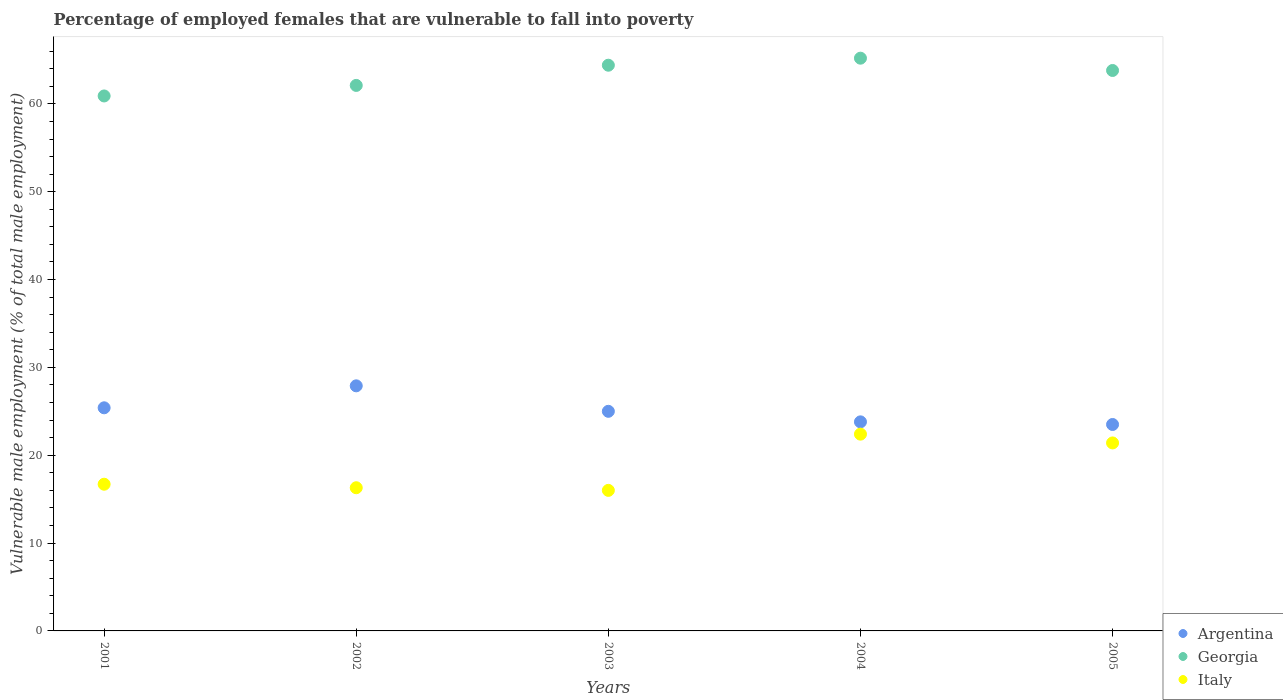How many different coloured dotlines are there?
Ensure brevity in your answer.  3. Is the number of dotlines equal to the number of legend labels?
Offer a terse response. Yes. What is the percentage of employed females who are vulnerable to fall into poverty in Argentina in 2004?
Give a very brief answer. 23.8. Across all years, what is the maximum percentage of employed females who are vulnerable to fall into poverty in Georgia?
Offer a terse response. 65.2. In which year was the percentage of employed females who are vulnerable to fall into poverty in Italy minimum?
Offer a terse response. 2003. What is the total percentage of employed females who are vulnerable to fall into poverty in Argentina in the graph?
Your answer should be very brief. 125.6. What is the difference between the percentage of employed females who are vulnerable to fall into poverty in Georgia in 2002 and that in 2005?
Make the answer very short. -1.7. What is the difference between the percentage of employed females who are vulnerable to fall into poverty in Italy in 2003 and the percentage of employed females who are vulnerable to fall into poverty in Argentina in 2005?
Keep it short and to the point. -7.5. What is the average percentage of employed females who are vulnerable to fall into poverty in Georgia per year?
Provide a succinct answer. 63.28. In the year 2004, what is the difference between the percentage of employed females who are vulnerable to fall into poverty in Argentina and percentage of employed females who are vulnerable to fall into poverty in Italy?
Offer a very short reply. 1.4. What is the ratio of the percentage of employed females who are vulnerable to fall into poverty in Georgia in 2001 to that in 2005?
Give a very brief answer. 0.95. Is the percentage of employed females who are vulnerable to fall into poverty in Italy in 2001 less than that in 2003?
Provide a short and direct response. No. Is the difference between the percentage of employed females who are vulnerable to fall into poverty in Argentina in 2002 and 2003 greater than the difference between the percentage of employed females who are vulnerable to fall into poverty in Italy in 2002 and 2003?
Offer a terse response. Yes. What is the difference between the highest and the lowest percentage of employed females who are vulnerable to fall into poverty in Georgia?
Make the answer very short. 4.3. Is it the case that in every year, the sum of the percentage of employed females who are vulnerable to fall into poverty in Italy and percentage of employed females who are vulnerable to fall into poverty in Argentina  is greater than the percentage of employed females who are vulnerable to fall into poverty in Georgia?
Offer a very short reply. No. Does the percentage of employed females who are vulnerable to fall into poverty in Italy monotonically increase over the years?
Give a very brief answer. No. Is the percentage of employed females who are vulnerable to fall into poverty in Argentina strictly greater than the percentage of employed females who are vulnerable to fall into poverty in Italy over the years?
Your answer should be very brief. Yes. Is the percentage of employed females who are vulnerable to fall into poverty in Argentina strictly less than the percentage of employed females who are vulnerable to fall into poverty in Georgia over the years?
Your answer should be very brief. Yes. How many dotlines are there?
Your response must be concise. 3. How many years are there in the graph?
Offer a terse response. 5. What is the difference between two consecutive major ticks on the Y-axis?
Your response must be concise. 10. Where does the legend appear in the graph?
Your response must be concise. Bottom right. How many legend labels are there?
Provide a succinct answer. 3. How are the legend labels stacked?
Your answer should be compact. Vertical. What is the title of the graph?
Ensure brevity in your answer.  Percentage of employed females that are vulnerable to fall into poverty. Does "Albania" appear as one of the legend labels in the graph?
Provide a succinct answer. No. What is the label or title of the Y-axis?
Provide a short and direct response. Vulnerable male employment (% of total male employment). What is the Vulnerable male employment (% of total male employment) in Argentina in 2001?
Make the answer very short. 25.4. What is the Vulnerable male employment (% of total male employment) in Georgia in 2001?
Your answer should be compact. 60.9. What is the Vulnerable male employment (% of total male employment) in Italy in 2001?
Provide a short and direct response. 16.7. What is the Vulnerable male employment (% of total male employment) of Argentina in 2002?
Offer a very short reply. 27.9. What is the Vulnerable male employment (% of total male employment) in Georgia in 2002?
Make the answer very short. 62.1. What is the Vulnerable male employment (% of total male employment) of Italy in 2002?
Your answer should be very brief. 16.3. What is the Vulnerable male employment (% of total male employment) of Argentina in 2003?
Your response must be concise. 25. What is the Vulnerable male employment (% of total male employment) in Georgia in 2003?
Provide a succinct answer. 64.4. What is the Vulnerable male employment (% of total male employment) in Argentina in 2004?
Keep it short and to the point. 23.8. What is the Vulnerable male employment (% of total male employment) in Georgia in 2004?
Your response must be concise. 65.2. What is the Vulnerable male employment (% of total male employment) of Italy in 2004?
Ensure brevity in your answer.  22.4. What is the Vulnerable male employment (% of total male employment) in Georgia in 2005?
Keep it short and to the point. 63.8. What is the Vulnerable male employment (% of total male employment) in Italy in 2005?
Keep it short and to the point. 21.4. Across all years, what is the maximum Vulnerable male employment (% of total male employment) in Argentina?
Offer a very short reply. 27.9. Across all years, what is the maximum Vulnerable male employment (% of total male employment) in Georgia?
Provide a succinct answer. 65.2. Across all years, what is the maximum Vulnerable male employment (% of total male employment) of Italy?
Keep it short and to the point. 22.4. Across all years, what is the minimum Vulnerable male employment (% of total male employment) of Argentina?
Provide a short and direct response. 23.5. Across all years, what is the minimum Vulnerable male employment (% of total male employment) in Georgia?
Keep it short and to the point. 60.9. Across all years, what is the minimum Vulnerable male employment (% of total male employment) of Italy?
Give a very brief answer. 16. What is the total Vulnerable male employment (% of total male employment) of Argentina in the graph?
Provide a succinct answer. 125.6. What is the total Vulnerable male employment (% of total male employment) of Georgia in the graph?
Your answer should be very brief. 316.4. What is the total Vulnerable male employment (% of total male employment) of Italy in the graph?
Give a very brief answer. 92.8. What is the difference between the Vulnerable male employment (% of total male employment) of Argentina in 2001 and that in 2002?
Offer a terse response. -2.5. What is the difference between the Vulnerable male employment (% of total male employment) in Georgia in 2001 and that in 2002?
Your response must be concise. -1.2. What is the difference between the Vulnerable male employment (% of total male employment) of Italy in 2001 and that in 2002?
Offer a very short reply. 0.4. What is the difference between the Vulnerable male employment (% of total male employment) of Argentina in 2001 and that in 2003?
Give a very brief answer. 0.4. What is the difference between the Vulnerable male employment (% of total male employment) in Georgia in 2001 and that in 2004?
Give a very brief answer. -4.3. What is the difference between the Vulnerable male employment (% of total male employment) in Argentina in 2001 and that in 2005?
Keep it short and to the point. 1.9. What is the difference between the Vulnerable male employment (% of total male employment) of Georgia in 2001 and that in 2005?
Keep it short and to the point. -2.9. What is the difference between the Vulnerable male employment (% of total male employment) of Italy in 2001 and that in 2005?
Offer a very short reply. -4.7. What is the difference between the Vulnerable male employment (% of total male employment) in Argentina in 2002 and that in 2003?
Make the answer very short. 2.9. What is the difference between the Vulnerable male employment (% of total male employment) of Georgia in 2002 and that in 2003?
Offer a terse response. -2.3. What is the difference between the Vulnerable male employment (% of total male employment) in Italy in 2002 and that in 2004?
Your answer should be very brief. -6.1. What is the difference between the Vulnerable male employment (% of total male employment) in Argentina in 2002 and that in 2005?
Provide a short and direct response. 4.4. What is the difference between the Vulnerable male employment (% of total male employment) in Italy in 2003 and that in 2004?
Your answer should be very brief. -6.4. What is the difference between the Vulnerable male employment (% of total male employment) in Italy in 2003 and that in 2005?
Make the answer very short. -5.4. What is the difference between the Vulnerable male employment (% of total male employment) in Argentina in 2001 and the Vulnerable male employment (% of total male employment) in Georgia in 2002?
Give a very brief answer. -36.7. What is the difference between the Vulnerable male employment (% of total male employment) in Georgia in 2001 and the Vulnerable male employment (% of total male employment) in Italy in 2002?
Offer a very short reply. 44.6. What is the difference between the Vulnerable male employment (% of total male employment) in Argentina in 2001 and the Vulnerable male employment (% of total male employment) in Georgia in 2003?
Your response must be concise. -39. What is the difference between the Vulnerable male employment (% of total male employment) of Argentina in 2001 and the Vulnerable male employment (% of total male employment) of Italy in 2003?
Give a very brief answer. 9.4. What is the difference between the Vulnerable male employment (% of total male employment) in Georgia in 2001 and the Vulnerable male employment (% of total male employment) in Italy in 2003?
Your response must be concise. 44.9. What is the difference between the Vulnerable male employment (% of total male employment) of Argentina in 2001 and the Vulnerable male employment (% of total male employment) of Georgia in 2004?
Keep it short and to the point. -39.8. What is the difference between the Vulnerable male employment (% of total male employment) in Argentina in 2001 and the Vulnerable male employment (% of total male employment) in Italy in 2004?
Offer a very short reply. 3. What is the difference between the Vulnerable male employment (% of total male employment) of Georgia in 2001 and the Vulnerable male employment (% of total male employment) of Italy in 2004?
Keep it short and to the point. 38.5. What is the difference between the Vulnerable male employment (% of total male employment) of Argentina in 2001 and the Vulnerable male employment (% of total male employment) of Georgia in 2005?
Make the answer very short. -38.4. What is the difference between the Vulnerable male employment (% of total male employment) of Argentina in 2001 and the Vulnerable male employment (% of total male employment) of Italy in 2005?
Give a very brief answer. 4. What is the difference between the Vulnerable male employment (% of total male employment) of Georgia in 2001 and the Vulnerable male employment (% of total male employment) of Italy in 2005?
Your answer should be compact. 39.5. What is the difference between the Vulnerable male employment (% of total male employment) in Argentina in 2002 and the Vulnerable male employment (% of total male employment) in Georgia in 2003?
Offer a very short reply. -36.5. What is the difference between the Vulnerable male employment (% of total male employment) of Argentina in 2002 and the Vulnerable male employment (% of total male employment) of Italy in 2003?
Provide a succinct answer. 11.9. What is the difference between the Vulnerable male employment (% of total male employment) of Georgia in 2002 and the Vulnerable male employment (% of total male employment) of Italy in 2003?
Offer a very short reply. 46.1. What is the difference between the Vulnerable male employment (% of total male employment) of Argentina in 2002 and the Vulnerable male employment (% of total male employment) of Georgia in 2004?
Keep it short and to the point. -37.3. What is the difference between the Vulnerable male employment (% of total male employment) in Georgia in 2002 and the Vulnerable male employment (% of total male employment) in Italy in 2004?
Your response must be concise. 39.7. What is the difference between the Vulnerable male employment (% of total male employment) of Argentina in 2002 and the Vulnerable male employment (% of total male employment) of Georgia in 2005?
Offer a very short reply. -35.9. What is the difference between the Vulnerable male employment (% of total male employment) of Argentina in 2002 and the Vulnerable male employment (% of total male employment) of Italy in 2005?
Provide a succinct answer. 6.5. What is the difference between the Vulnerable male employment (% of total male employment) of Georgia in 2002 and the Vulnerable male employment (% of total male employment) of Italy in 2005?
Your answer should be very brief. 40.7. What is the difference between the Vulnerable male employment (% of total male employment) in Argentina in 2003 and the Vulnerable male employment (% of total male employment) in Georgia in 2004?
Ensure brevity in your answer.  -40.2. What is the difference between the Vulnerable male employment (% of total male employment) in Argentina in 2003 and the Vulnerable male employment (% of total male employment) in Italy in 2004?
Your response must be concise. 2.6. What is the difference between the Vulnerable male employment (% of total male employment) in Argentina in 2003 and the Vulnerable male employment (% of total male employment) in Georgia in 2005?
Provide a short and direct response. -38.8. What is the difference between the Vulnerable male employment (% of total male employment) in Argentina in 2003 and the Vulnerable male employment (% of total male employment) in Italy in 2005?
Provide a short and direct response. 3.6. What is the difference between the Vulnerable male employment (% of total male employment) in Georgia in 2003 and the Vulnerable male employment (% of total male employment) in Italy in 2005?
Your response must be concise. 43. What is the difference between the Vulnerable male employment (% of total male employment) of Georgia in 2004 and the Vulnerable male employment (% of total male employment) of Italy in 2005?
Offer a very short reply. 43.8. What is the average Vulnerable male employment (% of total male employment) in Argentina per year?
Provide a succinct answer. 25.12. What is the average Vulnerable male employment (% of total male employment) in Georgia per year?
Offer a terse response. 63.28. What is the average Vulnerable male employment (% of total male employment) in Italy per year?
Provide a succinct answer. 18.56. In the year 2001, what is the difference between the Vulnerable male employment (% of total male employment) in Argentina and Vulnerable male employment (% of total male employment) in Georgia?
Your answer should be compact. -35.5. In the year 2001, what is the difference between the Vulnerable male employment (% of total male employment) of Georgia and Vulnerable male employment (% of total male employment) of Italy?
Give a very brief answer. 44.2. In the year 2002, what is the difference between the Vulnerable male employment (% of total male employment) of Argentina and Vulnerable male employment (% of total male employment) of Georgia?
Provide a short and direct response. -34.2. In the year 2002, what is the difference between the Vulnerable male employment (% of total male employment) of Georgia and Vulnerable male employment (% of total male employment) of Italy?
Your answer should be very brief. 45.8. In the year 2003, what is the difference between the Vulnerable male employment (% of total male employment) in Argentina and Vulnerable male employment (% of total male employment) in Georgia?
Offer a terse response. -39.4. In the year 2003, what is the difference between the Vulnerable male employment (% of total male employment) in Argentina and Vulnerable male employment (% of total male employment) in Italy?
Keep it short and to the point. 9. In the year 2003, what is the difference between the Vulnerable male employment (% of total male employment) of Georgia and Vulnerable male employment (% of total male employment) of Italy?
Provide a short and direct response. 48.4. In the year 2004, what is the difference between the Vulnerable male employment (% of total male employment) of Argentina and Vulnerable male employment (% of total male employment) of Georgia?
Keep it short and to the point. -41.4. In the year 2004, what is the difference between the Vulnerable male employment (% of total male employment) in Georgia and Vulnerable male employment (% of total male employment) in Italy?
Offer a very short reply. 42.8. In the year 2005, what is the difference between the Vulnerable male employment (% of total male employment) of Argentina and Vulnerable male employment (% of total male employment) of Georgia?
Offer a terse response. -40.3. In the year 2005, what is the difference between the Vulnerable male employment (% of total male employment) of Georgia and Vulnerable male employment (% of total male employment) of Italy?
Give a very brief answer. 42.4. What is the ratio of the Vulnerable male employment (% of total male employment) in Argentina in 2001 to that in 2002?
Offer a terse response. 0.91. What is the ratio of the Vulnerable male employment (% of total male employment) in Georgia in 2001 to that in 2002?
Make the answer very short. 0.98. What is the ratio of the Vulnerable male employment (% of total male employment) of Italy in 2001 to that in 2002?
Your response must be concise. 1.02. What is the ratio of the Vulnerable male employment (% of total male employment) in Argentina in 2001 to that in 2003?
Provide a succinct answer. 1.02. What is the ratio of the Vulnerable male employment (% of total male employment) in Georgia in 2001 to that in 2003?
Keep it short and to the point. 0.95. What is the ratio of the Vulnerable male employment (% of total male employment) in Italy in 2001 to that in 2003?
Provide a succinct answer. 1.04. What is the ratio of the Vulnerable male employment (% of total male employment) of Argentina in 2001 to that in 2004?
Provide a short and direct response. 1.07. What is the ratio of the Vulnerable male employment (% of total male employment) in Georgia in 2001 to that in 2004?
Your response must be concise. 0.93. What is the ratio of the Vulnerable male employment (% of total male employment) in Italy in 2001 to that in 2004?
Give a very brief answer. 0.75. What is the ratio of the Vulnerable male employment (% of total male employment) in Argentina in 2001 to that in 2005?
Offer a terse response. 1.08. What is the ratio of the Vulnerable male employment (% of total male employment) of Georgia in 2001 to that in 2005?
Provide a short and direct response. 0.95. What is the ratio of the Vulnerable male employment (% of total male employment) in Italy in 2001 to that in 2005?
Offer a very short reply. 0.78. What is the ratio of the Vulnerable male employment (% of total male employment) in Argentina in 2002 to that in 2003?
Provide a succinct answer. 1.12. What is the ratio of the Vulnerable male employment (% of total male employment) in Georgia in 2002 to that in 2003?
Offer a terse response. 0.96. What is the ratio of the Vulnerable male employment (% of total male employment) of Italy in 2002 to that in 2003?
Ensure brevity in your answer.  1.02. What is the ratio of the Vulnerable male employment (% of total male employment) of Argentina in 2002 to that in 2004?
Provide a short and direct response. 1.17. What is the ratio of the Vulnerable male employment (% of total male employment) in Georgia in 2002 to that in 2004?
Your answer should be compact. 0.95. What is the ratio of the Vulnerable male employment (% of total male employment) of Italy in 2002 to that in 2004?
Make the answer very short. 0.73. What is the ratio of the Vulnerable male employment (% of total male employment) in Argentina in 2002 to that in 2005?
Your answer should be very brief. 1.19. What is the ratio of the Vulnerable male employment (% of total male employment) of Georgia in 2002 to that in 2005?
Offer a terse response. 0.97. What is the ratio of the Vulnerable male employment (% of total male employment) in Italy in 2002 to that in 2005?
Give a very brief answer. 0.76. What is the ratio of the Vulnerable male employment (% of total male employment) in Argentina in 2003 to that in 2004?
Provide a short and direct response. 1.05. What is the ratio of the Vulnerable male employment (% of total male employment) in Georgia in 2003 to that in 2004?
Make the answer very short. 0.99. What is the ratio of the Vulnerable male employment (% of total male employment) of Italy in 2003 to that in 2004?
Provide a succinct answer. 0.71. What is the ratio of the Vulnerable male employment (% of total male employment) of Argentina in 2003 to that in 2005?
Provide a short and direct response. 1.06. What is the ratio of the Vulnerable male employment (% of total male employment) in Georgia in 2003 to that in 2005?
Your answer should be very brief. 1.01. What is the ratio of the Vulnerable male employment (% of total male employment) in Italy in 2003 to that in 2005?
Your answer should be compact. 0.75. What is the ratio of the Vulnerable male employment (% of total male employment) of Argentina in 2004 to that in 2005?
Offer a terse response. 1.01. What is the ratio of the Vulnerable male employment (% of total male employment) of Georgia in 2004 to that in 2005?
Offer a terse response. 1.02. What is the ratio of the Vulnerable male employment (% of total male employment) of Italy in 2004 to that in 2005?
Ensure brevity in your answer.  1.05. What is the difference between the highest and the lowest Vulnerable male employment (% of total male employment) in Argentina?
Ensure brevity in your answer.  4.4. 